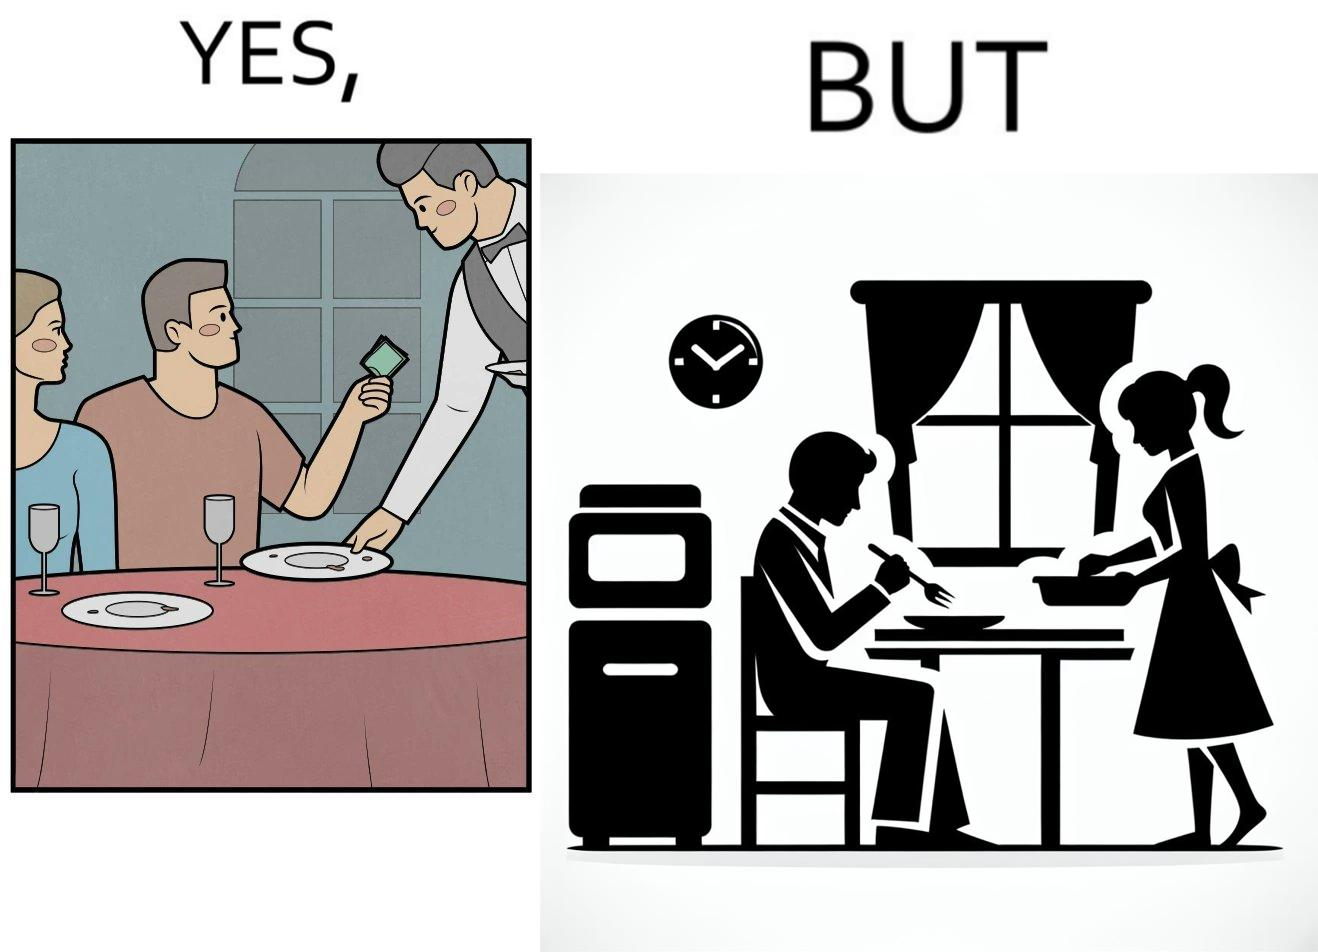What does this image depict? The image is ironical, as a man tips the waiter at a restaurant for the meal, but seems to not even acknowledge when his wife has made the meal for him at home. 